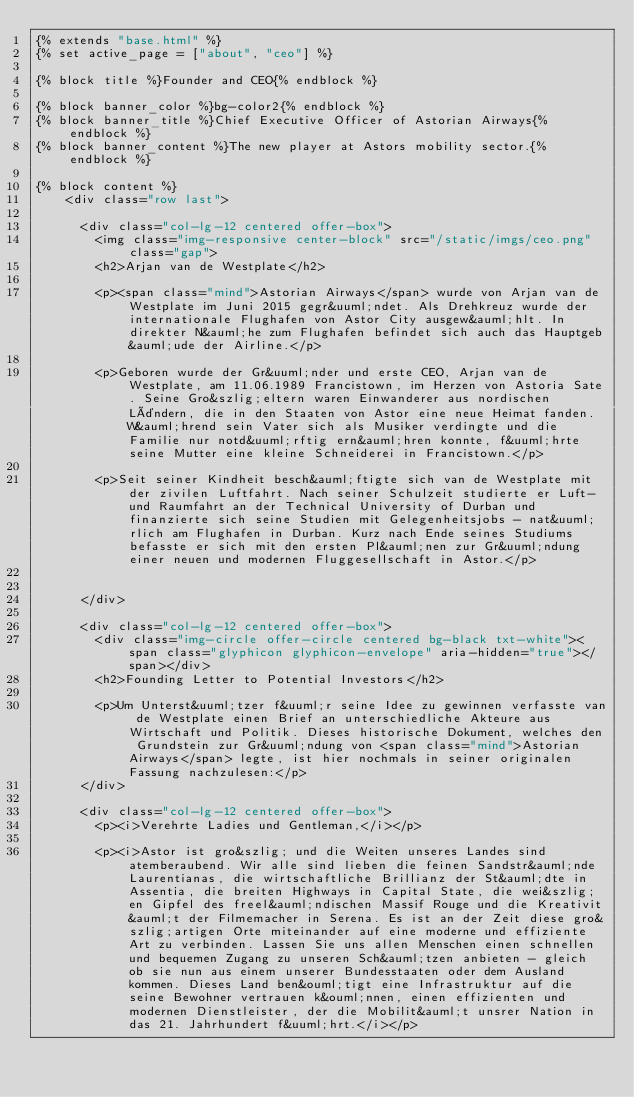Convert code to text. <code><loc_0><loc_0><loc_500><loc_500><_HTML_>{% extends "base.html" %}
{% set active_page = ["about", "ceo"] %}

{% block title %}Founder and CEO{% endblock %}

{% block banner_color %}bg-color2{% endblock %}
{% block banner_title %}Chief Executive Officer of Astorian Airways{% endblock %}
{% block banner_content %}The new player at Astors mobility sector.{% endblock %}

{% block content %}
    <div class="row last">

      <div class="col-lg-12 centered offer-box">
        <img class="img-responsive center-block" src="/static/imgs/ceo.png" class="gap">
        <h2>Arjan van de Westplate</h2>

        <p><span class="mind">Astorian Airways</span> wurde von Arjan van de Westplate im Juni 2015 gegr&uuml;ndet. Als Drehkreuz wurde der internationale Flughafen von Astor City ausgew&auml;hlt. In direkter N&auml;he zum Flughafen befindet sich auch das Hauptgeb&auml;ude der Airline.</p>

        <p>Geboren wurde der Gr&uuml;nder und erste CEO, Arjan van de Westplate, am 11.06.1989 Francistown, im Herzen von Astoria Sate. Seine Gro&szlig;eltern waren Einwanderer aus nordischen Ländern, die in den Staaten von Astor eine neue Heimat fanden. W&auml;hrend sein Vater sich als Musiker verdingte und die Familie nur notd&uuml;rftig ern&auml;hren konnte, f&uuml;hrte seine Mutter eine kleine Schneiderei in Francistown.</p>

        <p>Seit seiner Kindheit besch&auml;ftigte sich van de Westplate mit der zivilen Luftfahrt. Nach seiner Schulzeit studierte er Luft- und Raumfahrt an der Technical University of Durban und finanzierte sich seine Studien mit Gelegenheitsjobs - nat&uuml;rlich am Flughafen in Durban. Kurz nach Ende seines Studiums befasste er sich mit den ersten Pl&auml;nen zur Gr&uuml;ndung einer neuen und modernen Fluggesellschaft in Astor.</p>


      </div>

      <div class="col-lg-12 centered offer-box">
        <div class="img-circle offer-circle centered bg-black txt-white"><span class="glyphicon glyphicon-envelope" aria-hidden="true"></span></div>
        <h2>Founding Letter to Potential Investors</h2>

        <p>Um Unterst&uuml;tzer f&uuml;r seine Idee zu gewinnen verfasste van de Westplate einen Brief an unterschiedliche Akteure aus Wirtschaft und Politik. Dieses historische Dokument, welches den Grundstein zur Gr&uuml;ndung von <span class="mind">Astorian Airways</span> legte, ist hier nochmals in seiner originalen Fassung nachzulesen:</p>
      </div>

      <div class="col-lg-12 centered offer-box">
        <p><i>Verehrte Ladies und Gentleman,</i></p>

        <p><i>Astor ist gro&szlig; und die Weiten unseres Landes sind atemberaubend. Wir alle sind lieben die feinen Sandstr&auml;nde Laurentianas, die wirtschaftliche Brillianz der St&auml;dte in Assentia, die breiten Highways in Capital State, die wei&szlig;en Gipfel des freel&auml;ndischen Massif Rouge und die Kreativit&auml;t der Filmemacher in Serena. Es ist an der Zeit diese gro&szlig;artigen Orte miteinander auf eine moderne und effiziente Art zu verbinden. Lassen Sie uns allen Menschen einen schnellen und bequemen Zugang zu unseren Sch&auml;tzen anbieten - gleich ob sie nun aus einem unserer Bundesstaaten oder dem Ausland kommen. Dieses Land ben&ouml;tigt eine Infrastruktur auf die seine Bewohner vertrauen k&ouml;nnen, einen effizienten und modernen Dienstleister, der die Mobilit&auml;t unsrer Nation in das 21. Jahrhundert f&uuml;hrt.</i></p>
</code> 